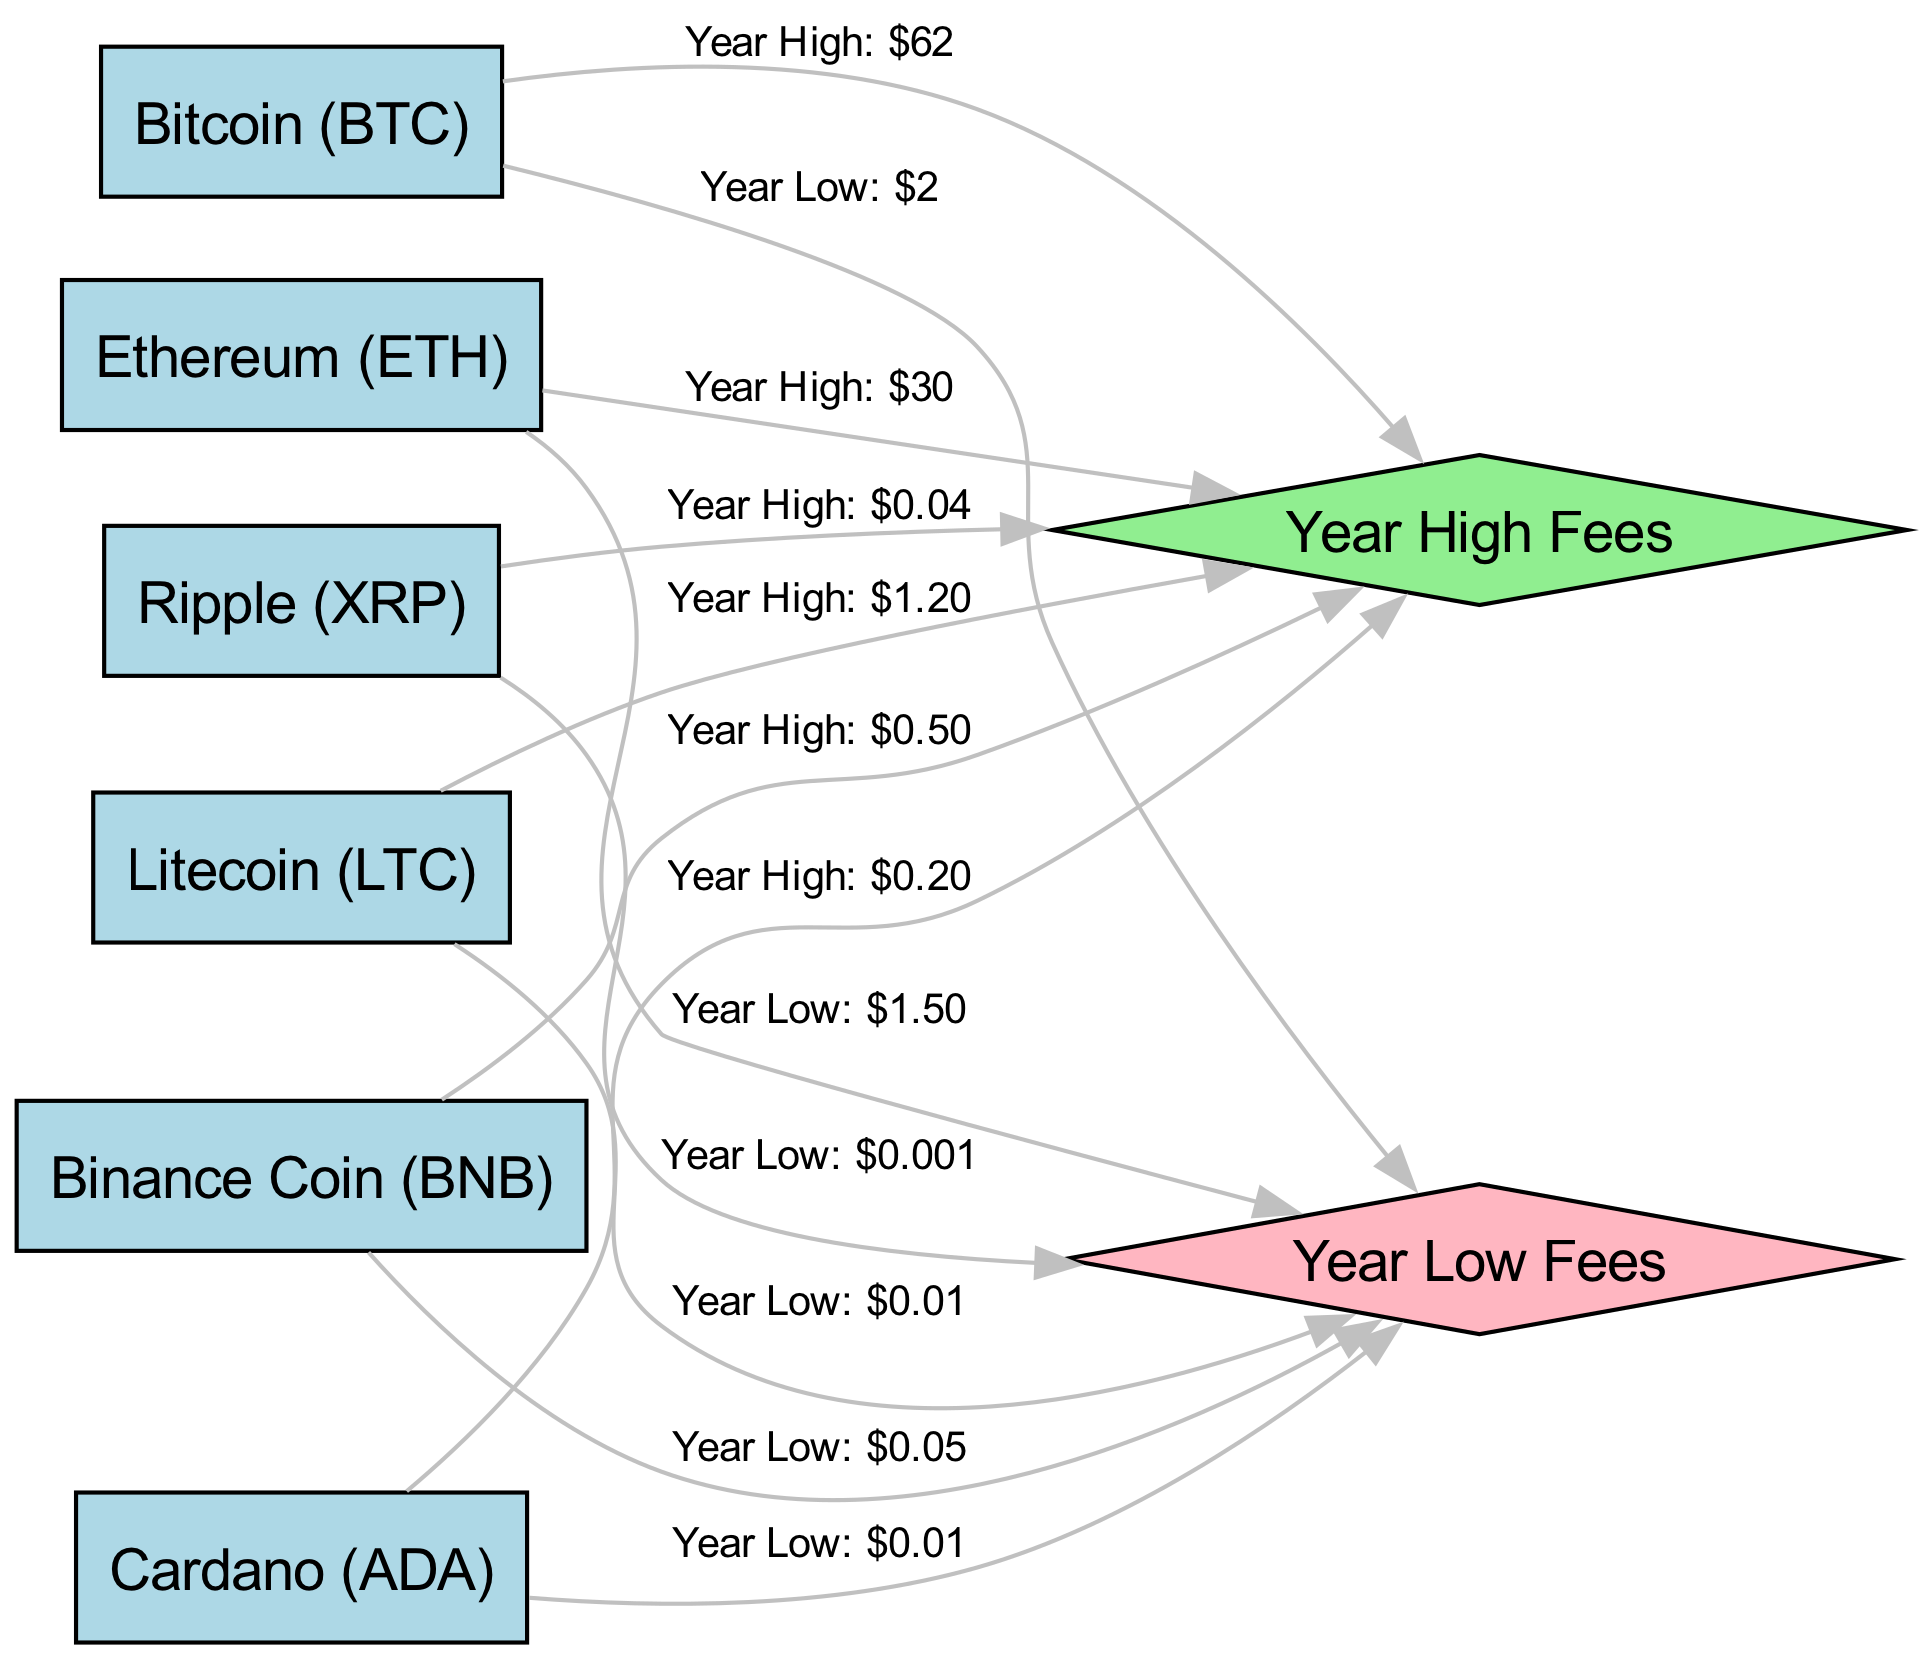What is the year high transaction fee for Bitcoin? The year high transaction fee for Bitcoin is directly labeled in the diagram, which states "Year High: $62". Therefore, the answer is found by locating the Bitcoin node and tracing the edge to the Year High node to find the labeled information.
Answer: $62 What is the year low transaction fee for Ethereum? The year low transaction fee for Ethereum is indicated in the diagram as "Year Low: $1.50". To find this information, I locate the Ethereum node and follow the edge leading to the Year Low fees node, noting the label there.
Answer: $1.50 How many nodes are present in the diagram? To determine the number of nodes, I count all individual nodes represented in the diagram, both cryptocurrencies and the Year High and Year Low nodes. There are 6 cryptocurrency nodes plus 2 more (Year High and Year Low), leading to a total count of 8 nodes.
Answer: 8 Which cryptocurrency has the highest year low fee? By examining the year low fees for each cryptocurrency, I see that Cardano has a year low fee of $0.01, which is the highest among the rest, as others are less than that. Thus, I compare all year low values and identify the correct node.
Answer: Cardano What is the difference between the year high fee of Bitcoin and the year low fee of Ripple? The year high fee of Bitcoin is $62 while the year low fee of Ripple is $0.001. To find the difference, I perform a subtraction: 62 - 0.001 = 61.999. This is calculated by checking the values of both the respective nodes.
Answer: 61.999 Which cryptocurrency has the lowest year high fee? Looking at the year high fees of all cryptocurrencies, Binance Coin shows a fee of $0.50, which is lower than the other year high fees. So, I identify the lowest value from the corresponding nodes, and thus reach the answer.
Answer: Binance Coin What is the average year high fee among these cryptocurrencies? To find the average year high fee, I would add up all the year high fees ($62 + $30 + $0.50 + $1.20 + $0.04 + $0.20 = $93.94) and then divide by the number of cryptocurrencies (which is 6). The average fee comes to approximately $15.66 after calculating and rounding where necessary.
Answer: 15.66 Identify the cryptocurrency with the second highest year high fee. After evaluating the year high fees listed for all cryptocurrencies, Bitcoin presents the highest fee at $62, while Ethereum at $30 follows as the second highest. I list the fees in descending order and find the next one accordingly.
Answer: Ethereum 